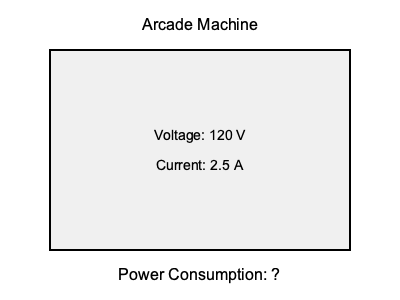You've helped build an arcade machine that operates on 120 volts and draws 2.5 amperes of current. What is the power consumption of this arcade machine in watts? To calculate the power consumption of the arcade machine, we need to use the formula for electrical power:

$$ P = V \times I $$

Where:
$P$ = Power (in watts, W)
$V$ = Voltage (in volts, V)
$I$ = Current (in amperes, A)

Given:
$V = 120$ V
$I = 2.5$ A

Let's substitute these values into the formula:

$$ P = 120 \text{ V} \times 2.5 \text{ A} $$

Now, let's multiply:

$$ P = 300 \text{ W} $$

Therefore, the power consumption of the arcade machine is 300 watts.
Answer: 300 W 